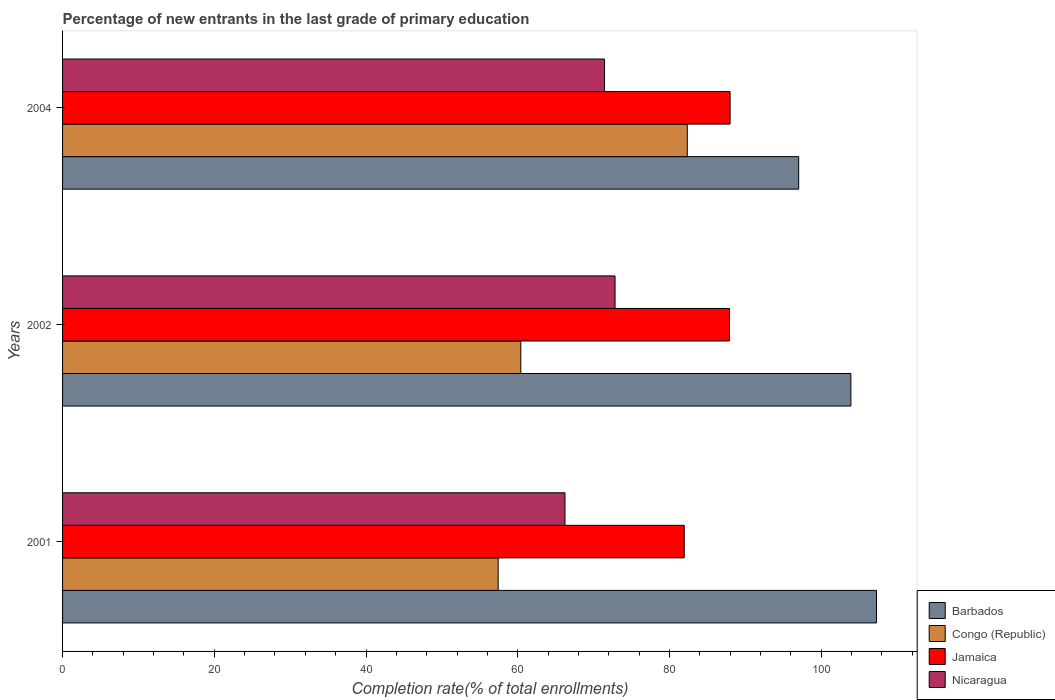How many groups of bars are there?
Your answer should be compact. 3. Are the number of bars per tick equal to the number of legend labels?
Provide a short and direct response. Yes. Are the number of bars on each tick of the Y-axis equal?
Provide a succinct answer. Yes. How many bars are there on the 3rd tick from the bottom?
Make the answer very short. 4. What is the label of the 2nd group of bars from the top?
Keep it short and to the point. 2002. In how many cases, is the number of bars for a given year not equal to the number of legend labels?
Make the answer very short. 0. What is the percentage of new entrants in Nicaragua in 2001?
Ensure brevity in your answer.  66.23. Across all years, what is the maximum percentage of new entrants in Congo (Republic)?
Give a very brief answer. 82.35. Across all years, what is the minimum percentage of new entrants in Jamaica?
Ensure brevity in your answer.  81.95. In which year was the percentage of new entrants in Nicaragua maximum?
Ensure brevity in your answer.  2002. In which year was the percentage of new entrants in Jamaica minimum?
Your answer should be compact. 2001. What is the total percentage of new entrants in Barbados in the graph?
Your answer should be very brief. 308.24. What is the difference between the percentage of new entrants in Barbados in 2001 and that in 2004?
Your answer should be very brief. 10.26. What is the difference between the percentage of new entrants in Congo (Republic) in 2001 and the percentage of new entrants in Jamaica in 2002?
Give a very brief answer. -30.49. What is the average percentage of new entrants in Congo (Republic) per year?
Your response must be concise. 66.72. In the year 2004, what is the difference between the percentage of new entrants in Congo (Republic) and percentage of new entrants in Jamaica?
Give a very brief answer. -5.64. What is the ratio of the percentage of new entrants in Jamaica in 2001 to that in 2002?
Offer a terse response. 0.93. What is the difference between the highest and the second highest percentage of new entrants in Congo (Republic)?
Make the answer very short. 21.95. What is the difference between the highest and the lowest percentage of new entrants in Nicaragua?
Offer a very short reply. 6.6. Is the sum of the percentage of new entrants in Nicaragua in 2002 and 2004 greater than the maximum percentage of new entrants in Jamaica across all years?
Make the answer very short. Yes. What does the 1st bar from the top in 2004 represents?
Ensure brevity in your answer.  Nicaragua. What does the 2nd bar from the bottom in 2001 represents?
Keep it short and to the point. Congo (Republic). Are all the bars in the graph horizontal?
Give a very brief answer. Yes. How many years are there in the graph?
Keep it short and to the point. 3. Does the graph contain any zero values?
Provide a short and direct response. No. How are the legend labels stacked?
Offer a very short reply. Vertical. What is the title of the graph?
Offer a very short reply. Percentage of new entrants in the last grade of primary education. What is the label or title of the X-axis?
Offer a very short reply. Completion rate(% of total enrollments). What is the label or title of the Y-axis?
Your response must be concise. Years. What is the Completion rate(% of total enrollments) of Barbados in 2001?
Offer a terse response. 107.29. What is the Completion rate(% of total enrollments) in Congo (Republic) in 2001?
Provide a short and direct response. 57.42. What is the Completion rate(% of total enrollments) in Jamaica in 2001?
Your answer should be compact. 81.95. What is the Completion rate(% of total enrollments) in Nicaragua in 2001?
Give a very brief answer. 66.23. What is the Completion rate(% of total enrollments) in Barbados in 2002?
Keep it short and to the point. 103.91. What is the Completion rate(% of total enrollments) in Congo (Republic) in 2002?
Keep it short and to the point. 60.4. What is the Completion rate(% of total enrollments) of Jamaica in 2002?
Ensure brevity in your answer.  87.91. What is the Completion rate(% of total enrollments) in Nicaragua in 2002?
Your answer should be compact. 72.83. What is the Completion rate(% of total enrollments) in Barbados in 2004?
Keep it short and to the point. 97.03. What is the Completion rate(% of total enrollments) of Congo (Republic) in 2004?
Give a very brief answer. 82.35. What is the Completion rate(% of total enrollments) in Jamaica in 2004?
Ensure brevity in your answer.  87.99. What is the Completion rate(% of total enrollments) in Nicaragua in 2004?
Ensure brevity in your answer.  71.44. Across all years, what is the maximum Completion rate(% of total enrollments) of Barbados?
Offer a very short reply. 107.29. Across all years, what is the maximum Completion rate(% of total enrollments) of Congo (Republic)?
Make the answer very short. 82.35. Across all years, what is the maximum Completion rate(% of total enrollments) of Jamaica?
Your answer should be very brief. 87.99. Across all years, what is the maximum Completion rate(% of total enrollments) of Nicaragua?
Give a very brief answer. 72.83. Across all years, what is the minimum Completion rate(% of total enrollments) of Barbados?
Make the answer very short. 97.03. Across all years, what is the minimum Completion rate(% of total enrollments) of Congo (Republic)?
Make the answer very short. 57.42. Across all years, what is the minimum Completion rate(% of total enrollments) in Jamaica?
Provide a succinct answer. 81.95. Across all years, what is the minimum Completion rate(% of total enrollments) of Nicaragua?
Ensure brevity in your answer.  66.23. What is the total Completion rate(% of total enrollments) in Barbados in the graph?
Ensure brevity in your answer.  308.24. What is the total Completion rate(% of total enrollments) in Congo (Republic) in the graph?
Give a very brief answer. 200.17. What is the total Completion rate(% of total enrollments) of Jamaica in the graph?
Your response must be concise. 257.84. What is the total Completion rate(% of total enrollments) of Nicaragua in the graph?
Ensure brevity in your answer.  210.5. What is the difference between the Completion rate(% of total enrollments) of Barbados in 2001 and that in 2002?
Your response must be concise. 3.37. What is the difference between the Completion rate(% of total enrollments) of Congo (Republic) in 2001 and that in 2002?
Give a very brief answer. -2.98. What is the difference between the Completion rate(% of total enrollments) of Jamaica in 2001 and that in 2002?
Keep it short and to the point. -5.96. What is the difference between the Completion rate(% of total enrollments) of Nicaragua in 2001 and that in 2002?
Make the answer very short. -6.6. What is the difference between the Completion rate(% of total enrollments) in Barbados in 2001 and that in 2004?
Offer a very short reply. 10.26. What is the difference between the Completion rate(% of total enrollments) of Congo (Republic) in 2001 and that in 2004?
Provide a short and direct response. -24.93. What is the difference between the Completion rate(% of total enrollments) in Jamaica in 2001 and that in 2004?
Make the answer very short. -6.04. What is the difference between the Completion rate(% of total enrollments) in Nicaragua in 2001 and that in 2004?
Keep it short and to the point. -5.21. What is the difference between the Completion rate(% of total enrollments) of Barbados in 2002 and that in 2004?
Make the answer very short. 6.88. What is the difference between the Completion rate(% of total enrollments) of Congo (Republic) in 2002 and that in 2004?
Keep it short and to the point. -21.95. What is the difference between the Completion rate(% of total enrollments) in Jamaica in 2002 and that in 2004?
Provide a succinct answer. -0.08. What is the difference between the Completion rate(% of total enrollments) in Nicaragua in 2002 and that in 2004?
Your answer should be compact. 1.38. What is the difference between the Completion rate(% of total enrollments) in Barbados in 2001 and the Completion rate(% of total enrollments) in Congo (Republic) in 2002?
Provide a succinct answer. 46.89. What is the difference between the Completion rate(% of total enrollments) of Barbados in 2001 and the Completion rate(% of total enrollments) of Jamaica in 2002?
Provide a short and direct response. 19.38. What is the difference between the Completion rate(% of total enrollments) in Barbados in 2001 and the Completion rate(% of total enrollments) in Nicaragua in 2002?
Your answer should be compact. 34.46. What is the difference between the Completion rate(% of total enrollments) in Congo (Republic) in 2001 and the Completion rate(% of total enrollments) in Jamaica in 2002?
Offer a terse response. -30.49. What is the difference between the Completion rate(% of total enrollments) of Congo (Republic) in 2001 and the Completion rate(% of total enrollments) of Nicaragua in 2002?
Your answer should be very brief. -15.41. What is the difference between the Completion rate(% of total enrollments) of Jamaica in 2001 and the Completion rate(% of total enrollments) of Nicaragua in 2002?
Provide a succinct answer. 9.12. What is the difference between the Completion rate(% of total enrollments) of Barbados in 2001 and the Completion rate(% of total enrollments) of Congo (Republic) in 2004?
Keep it short and to the point. 24.94. What is the difference between the Completion rate(% of total enrollments) of Barbados in 2001 and the Completion rate(% of total enrollments) of Jamaica in 2004?
Make the answer very short. 19.3. What is the difference between the Completion rate(% of total enrollments) of Barbados in 2001 and the Completion rate(% of total enrollments) of Nicaragua in 2004?
Provide a short and direct response. 35.85. What is the difference between the Completion rate(% of total enrollments) in Congo (Republic) in 2001 and the Completion rate(% of total enrollments) in Jamaica in 2004?
Ensure brevity in your answer.  -30.57. What is the difference between the Completion rate(% of total enrollments) of Congo (Republic) in 2001 and the Completion rate(% of total enrollments) of Nicaragua in 2004?
Your answer should be compact. -14.02. What is the difference between the Completion rate(% of total enrollments) of Jamaica in 2001 and the Completion rate(% of total enrollments) of Nicaragua in 2004?
Offer a very short reply. 10.5. What is the difference between the Completion rate(% of total enrollments) in Barbados in 2002 and the Completion rate(% of total enrollments) in Congo (Republic) in 2004?
Ensure brevity in your answer.  21.57. What is the difference between the Completion rate(% of total enrollments) in Barbados in 2002 and the Completion rate(% of total enrollments) in Jamaica in 2004?
Your answer should be compact. 15.92. What is the difference between the Completion rate(% of total enrollments) in Barbados in 2002 and the Completion rate(% of total enrollments) in Nicaragua in 2004?
Keep it short and to the point. 32.47. What is the difference between the Completion rate(% of total enrollments) of Congo (Republic) in 2002 and the Completion rate(% of total enrollments) of Jamaica in 2004?
Your response must be concise. -27.59. What is the difference between the Completion rate(% of total enrollments) of Congo (Republic) in 2002 and the Completion rate(% of total enrollments) of Nicaragua in 2004?
Offer a terse response. -11.04. What is the difference between the Completion rate(% of total enrollments) in Jamaica in 2002 and the Completion rate(% of total enrollments) in Nicaragua in 2004?
Ensure brevity in your answer.  16.46. What is the average Completion rate(% of total enrollments) of Barbados per year?
Ensure brevity in your answer.  102.75. What is the average Completion rate(% of total enrollments) of Congo (Republic) per year?
Your response must be concise. 66.72. What is the average Completion rate(% of total enrollments) of Jamaica per year?
Your answer should be compact. 85.95. What is the average Completion rate(% of total enrollments) in Nicaragua per year?
Your response must be concise. 70.17. In the year 2001, what is the difference between the Completion rate(% of total enrollments) in Barbados and Completion rate(% of total enrollments) in Congo (Republic)?
Offer a very short reply. 49.87. In the year 2001, what is the difference between the Completion rate(% of total enrollments) in Barbados and Completion rate(% of total enrollments) in Jamaica?
Give a very brief answer. 25.34. In the year 2001, what is the difference between the Completion rate(% of total enrollments) of Barbados and Completion rate(% of total enrollments) of Nicaragua?
Provide a succinct answer. 41.06. In the year 2001, what is the difference between the Completion rate(% of total enrollments) in Congo (Republic) and Completion rate(% of total enrollments) in Jamaica?
Offer a very short reply. -24.53. In the year 2001, what is the difference between the Completion rate(% of total enrollments) of Congo (Republic) and Completion rate(% of total enrollments) of Nicaragua?
Your response must be concise. -8.81. In the year 2001, what is the difference between the Completion rate(% of total enrollments) of Jamaica and Completion rate(% of total enrollments) of Nicaragua?
Your answer should be very brief. 15.72. In the year 2002, what is the difference between the Completion rate(% of total enrollments) of Barbados and Completion rate(% of total enrollments) of Congo (Republic)?
Provide a short and direct response. 43.51. In the year 2002, what is the difference between the Completion rate(% of total enrollments) of Barbados and Completion rate(% of total enrollments) of Jamaica?
Provide a short and direct response. 16.01. In the year 2002, what is the difference between the Completion rate(% of total enrollments) of Barbados and Completion rate(% of total enrollments) of Nicaragua?
Your answer should be compact. 31.09. In the year 2002, what is the difference between the Completion rate(% of total enrollments) in Congo (Republic) and Completion rate(% of total enrollments) in Jamaica?
Offer a very short reply. -27.5. In the year 2002, what is the difference between the Completion rate(% of total enrollments) of Congo (Republic) and Completion rate(% of total enrollments) of Nicaragua?
Keep it short and to the point. -12.42. In the year 2002, what is the difference between the Completion rate(% of total enrollments) of Jamaica and Completion rate(% of total enrollments) of Nicaragua?
Keep it short and to the point. 15.08. In the year 2004, what is the difference between the Completion rate(% of total enrollments) in Barbados and Completion rate(% of total enrollments) in Congo (Republic)?
Ensure brevity in your answer.  14.69. In the year 2004, what is the difference between the Completion rate(% of total enrollments) of Barbados and Completion rate(% of total enrollments) of Jamaica?
Offer a very short reply. 9.04. In the year 2004, what is the difference between the Completion rate(% of total enrollments) in Barbados and Completion rate(% of total enrollments) in Nicaragua?
Your answer should be very brief. 25.59. In the year 2004, what is the difference between the Completion rate(% of total enrollments) in Congo (Republic) and Completion rate(% of total enrollments) in Jamaica?
Ensure brevity in your answer.  -5.64. In the year 2004, what is the difference between the Completion rate(% of total enrollments) in Congo (Republic) and Completion rate(% of total enrollments) in Nicaragua?
Offer a very short reply. 10.91. In the year 2004, what is the difference between the Completion rate(% of total enrollments) in Jamaica and Completion rate(% of total enrollments) in Nicaragua?
Your answer should be very brief. 16.55. What is the ratio of the Completion rate(% of total enrollments) of Barbados in 2001 to that in 2002?
Provide a succinct answer. 1.03. What is the ratio of the Completion rate(% of total enrollments) of Congo (Republic) in 2001 to that in 2002?
Give a very brief answer. 0.95. What is the ratio of the Completion rate(% of total enrollments) in Jamaica in 2001 to that in 2002?
Your answer should be very brief. 0.93. What is the ratio of the Completion rate(% of total enrollments) of Nicaragua in 2001 to that in 2002?
Provide a short and direct response. 0.91. What is the ratio of the Completion rate(% of total enrollments) of Barbados in 2001 to that in 2004?
Your answer should be very brief. 1.11. What is the ratio of the Completion rate(% of total enrollments) in Congo (Republic) in 2001 to that in 2004?
Offer a very short reply. 0.7. What is the ratio of the Completion rate(% of total enrollments) in Jamaica in 2001 to that in 2004?
Give a very brief answer. 0.93. What is the ratio of the Completion rate(% of total enrollments) of Nicaragua in 2001 to that in 2004?
Keep it short and to the point. 0.93. What is the ratio of the Completion rate(% of total enrollments) in Barbados in 2002 to that in 2004?
Provide a short and direct response. 1.07. What is the ratio of the Completion rate(% of total enrollments) of Congo (Republic) in 2002 to that in 2004?
Your answer should be compact. 0.73. What is the ratio of the Completion rate(% of total enrollments) of Jamaica in 2002 to that in 2004?
Your answer should be very brief. 1. What is the ratio of the Completion rate(% of total enrollments) of Nicaragua in 2002 to that in 2004?
Provide a succinct answer. 1.02. What is the difference between the highest and the second highest Completion rate(% of total enrollments) of Barbados?
Make the answer very short. 3.37. What is the difference between the highest and the second highest Completion rate(% of total enrollments) in Congo (Republic)?
Make the answer very short. 21.95. What is the difference between the highest and the second highest Completion rate(% of total enrollments) of Jamaica?
Offer a very short reply. 0.08. What is the difference between the highest and the second highest Completion rate(% of total enrollments) in Nicaragua?
Your answer should be very brief. 1.38. What is the difference between the highest and the lowest Completion rate(% of total enrollments) in Barbados?
Your response must be concise. 10.26. What is the difference between the highest and the lowest Completion rate(% of total enrollments) in Congo (Republic)?
Keep it short and to the point. 24.93. What is the difference between the highest and the lowest Completion rate(% of total enrollments) of Jamaica?
Offer a terse response. 6.04. What is the difference between the highest and the lowest Completion rate(% of total enrollments) of Nicaragua?
Provide a succinct answer. 6.6. 